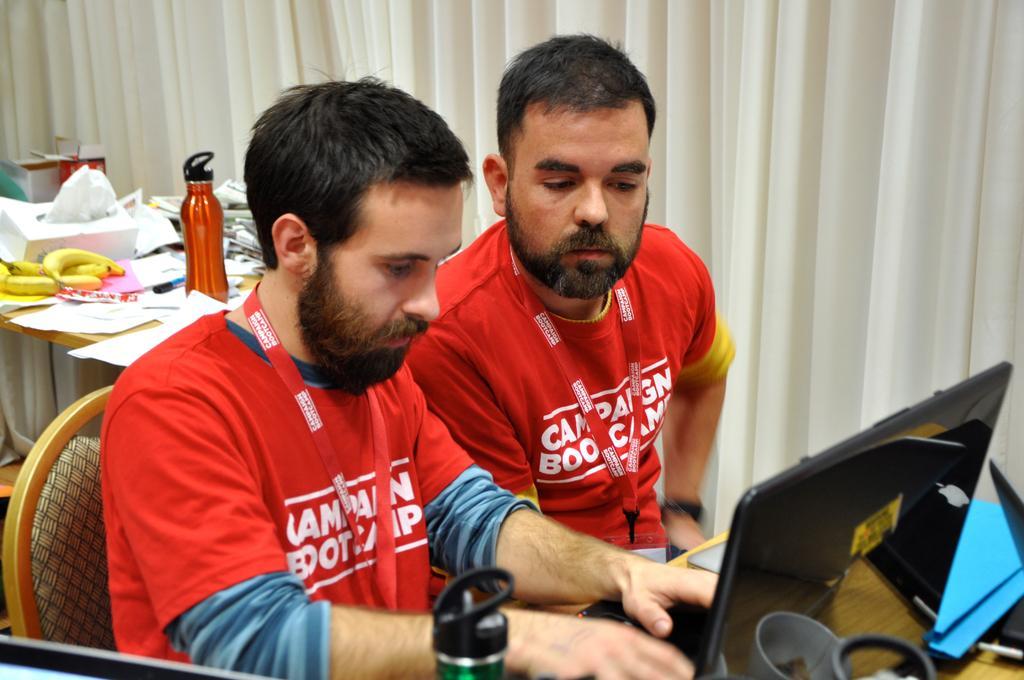In one or two sentences, can you explain what this image depicts? In this picture there is a man who is wearing a red shirt is sitting on the chair and is looking into the laptop. There is another man who is sitting on the chair and is looking into the laptop. At the back, there is a bottle and few bananas on the table. There is a paper on the table. 